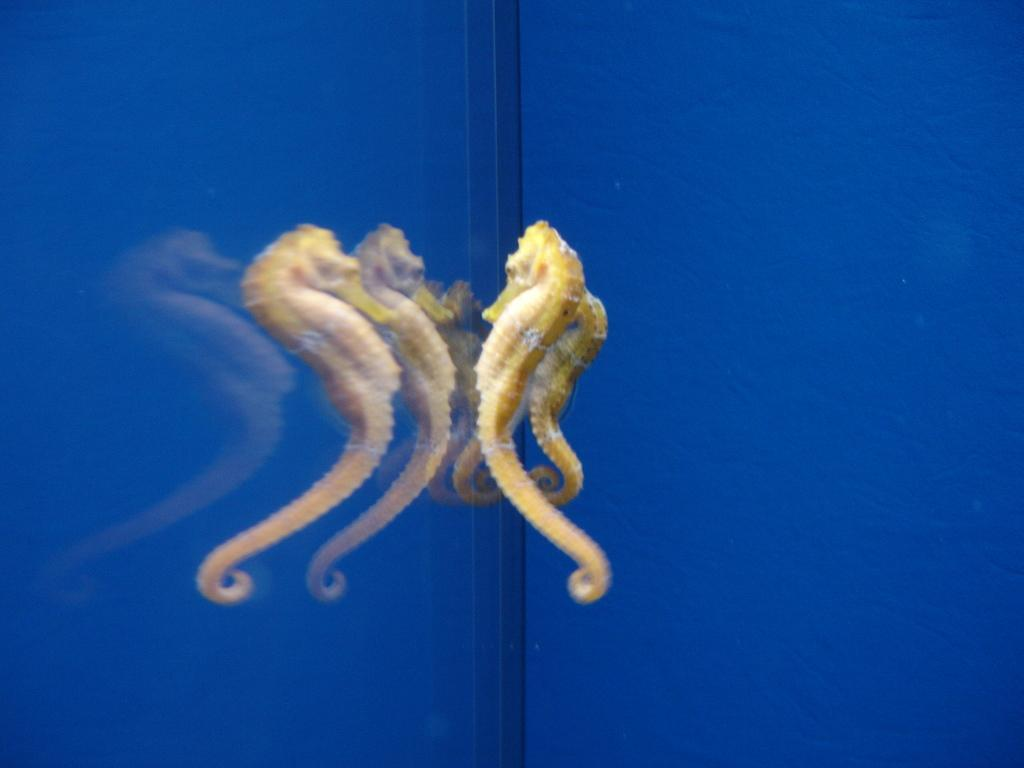What is the main object in the picture? There is an aquarium in the picture. What color is the aquarium? The aquarium is blue in color. What material is the aquarium made of? The aquarium has glass. How many seahorses are in the aquarium? There are two seahorses in the aquarium. Can you see the seahorses' reflections in the picture? Yes, the seahorses' reflections are visible on the glass. What type of agreement was reached during the recess in the image? There is no indication of an agreement or a recess in the image, as it features an aquarium with seahorses. 